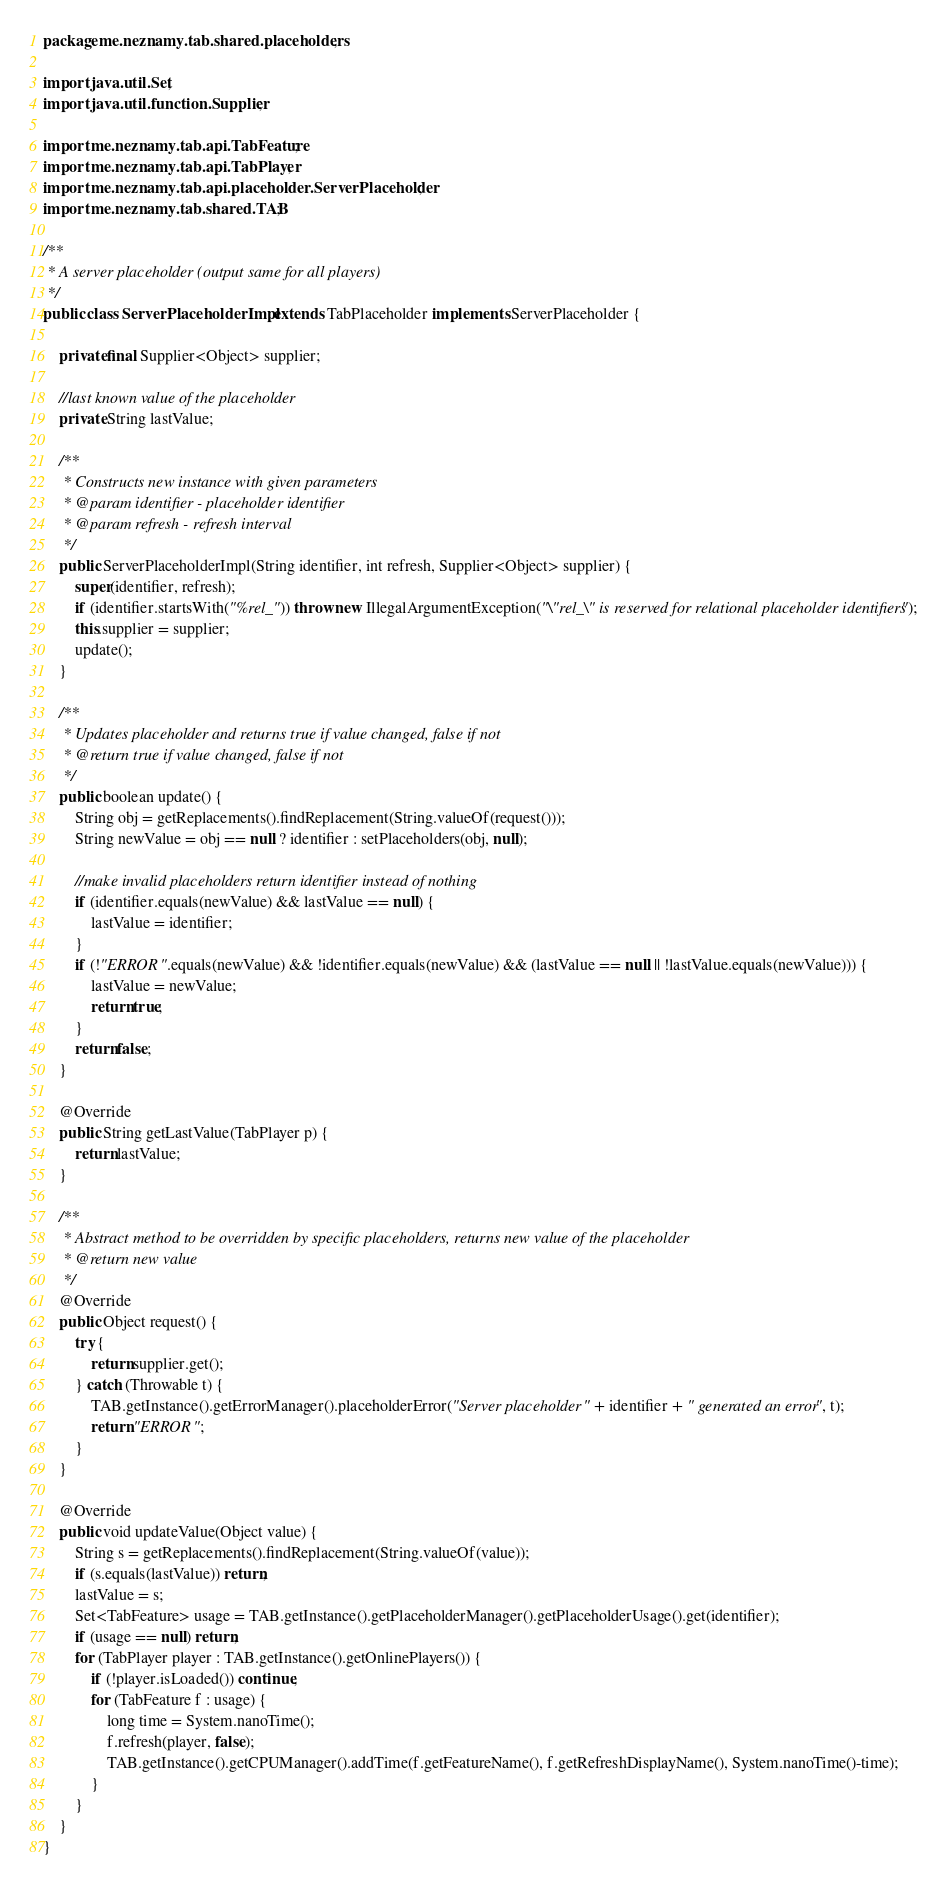Convert code to text. <code><loc_0><loc_0><loc_500><loc_500><_Java_>package me.neznamy.tab.shared.placeholders;

import java.util.Set;
import java.util.function.Supplier;

import me.neznamy.tab.api.TabFeature;
import me.neznamy.tab.api.TabPlayer;
import me.neznamy.tab.api.placeholder.ServerPlaceholder;
import me.neznamy.tab.shared.TAB;

/**
 * A server placeholder (output same for all players)
 */
public class ServerPlaceholderImpl extends TabPlaceholder implements ServerPlaceholder {

	private final Supplier<Object> supplier;
	
	//last known value of the placeholder
	private String lastValue;

	/**
	 * Constructs new instance with given parameters
	 * @param identifier - placeholder identifier
	 * @param refresh - refresh interval
	 */
	public ServerPlaceholderImpl(String identifier, int refresh, Supplier<Object> supplier) {
		super(identifier, refresh);
		if (identifier.startsWith("%rel_")) throw new IllegalArgumentException("\"rel_\" is reserved for relational placeholder identifiers");
		this.supplier = supplier;
		update();
	}
	
	/**
	 * Updates placeholder and returns true if value changed, false if not
	 * @return true if value changed, false if not
	 */
	public boolean update() {
		String obj = getReplacements().findReplacement(String.valueOf(request()));
		String newValue = obj == null ? identifier : setPlaceholders(obj, null);
		
		//make invalid placeholders return identifier instead of nothing
		if (identifier.equals(newValue) && lastValue == null) {
			lastValue = identifier;
		}
		if (!"ERROR".equals(newValue) && !identifier.equals(newValue) && (lastValue == null || !lastValue.equals(newValue))) {
			lastValue = newValue;
			return true;
		}
		return false;
	}

	@Override
	public String getLastValue(TabPlayer p) {
		return lastValue;
	}

	/**
	 * Abstract method to be overridden by specific placeholders, returns new value of the placeholder
	 * @return new value
	 */
	@Override
	public Object request() {
		try {
			return supplier.get();
		} catch (Throwable t) {
			TAB.getInstance().getErrorManager().placeholderError("Server placeholder " + identifier + " generated an error", t);
			return "ERROR";
		}
	}

	@Override
	public void updateValue(Object value) {
		String s = getReplacements().findReplacement(String.valueOf(value));
		if (s.equals(lastValue)) return;
		lastValue = s;
		Set<TabFeature> usage = TAB.getInstance().getPlaceholderManager().getPlaceholderUsage().get(identifier);
		if (usage == null) return;
		for (TabPlayer player : TAB.getInstance().getOnlinePlayers()) {
			if (!player.isLoaded()) continue;
			for (TabFeature f : usage) {
				long time = System.nanoTime();
				f.refresh(player, false);
				TAB.getInstance().getCPUManager().addTime(f.getFeatureName(), f.getRefreshDisplayName(), System.nanoTime()-time);
			}
		}
	}
}</code> 